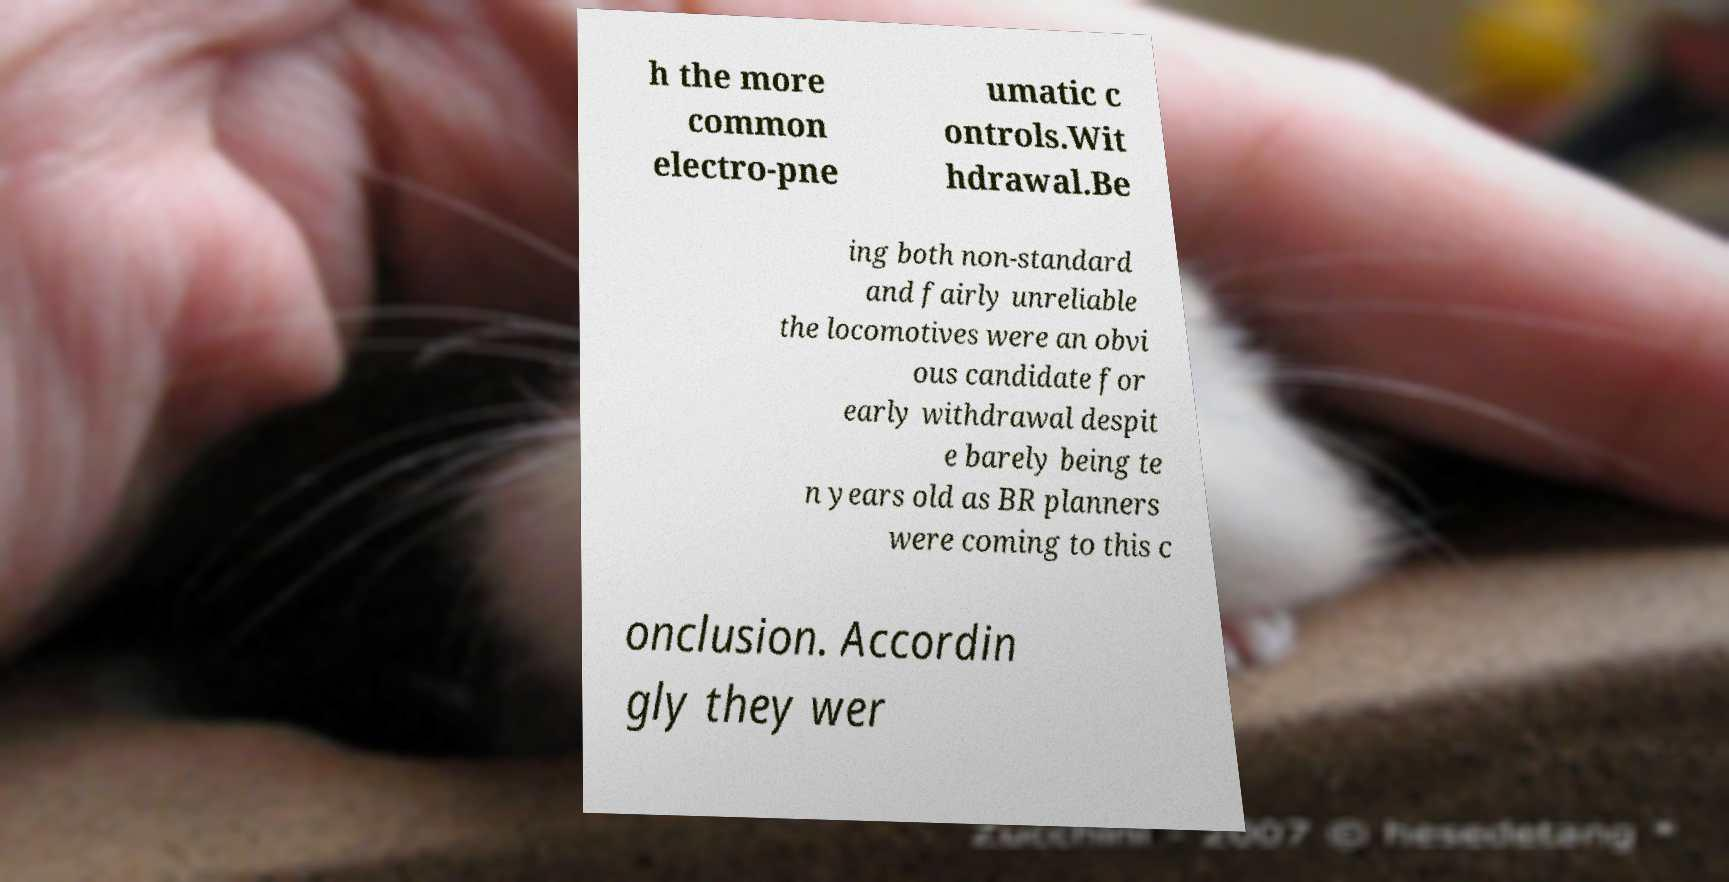Please identify and transcribe the text found in this image. h the more common electro-pne umatic c ontrols.Wit hdrawal.Be ing both non-standard and fairly unreliable the locomotives were an obvi ous candidate for early withdrawal despit e barely being te n years old as BR planners were coming to this c onclusion. Accordin gly they wer 